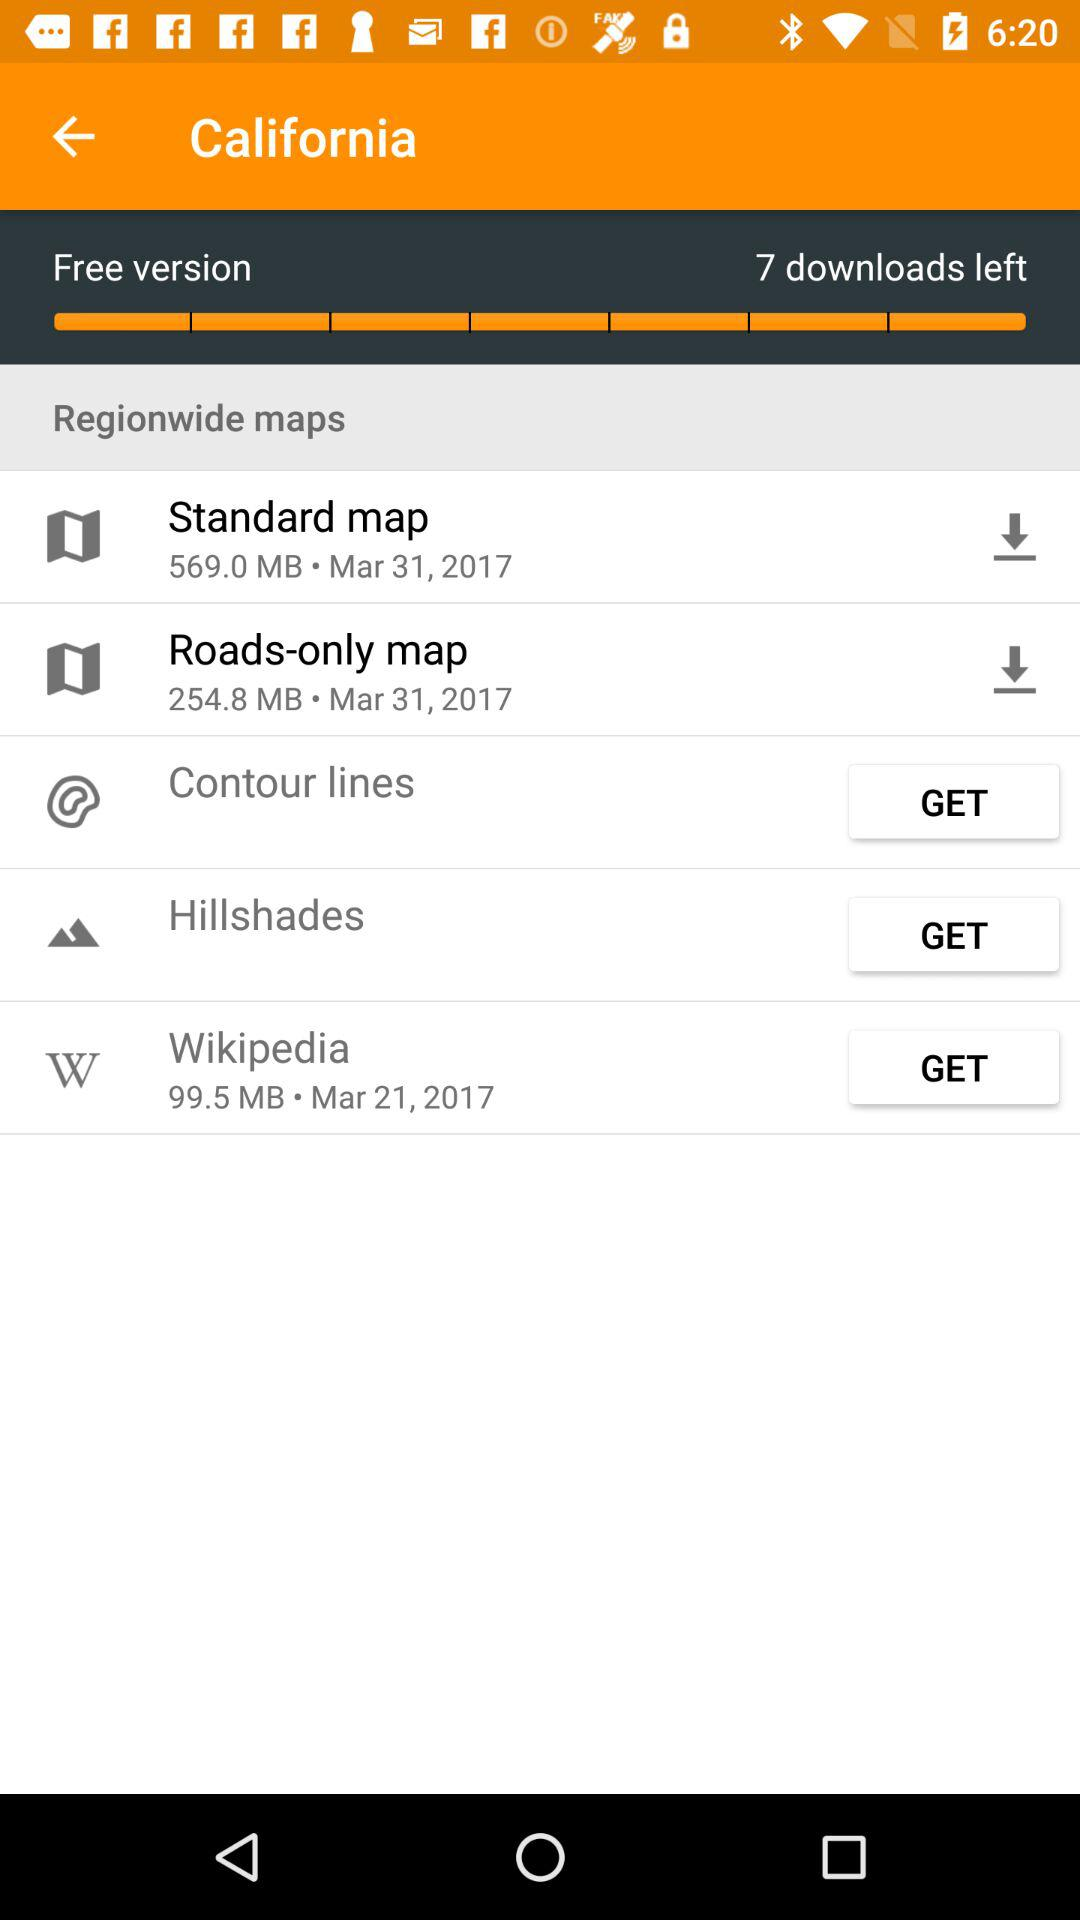What is the size of the standard map? The size of the standard map is 569.0 MB. 